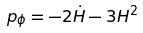<formula> <loc_0><loc_0><loc_500><loc_500>p _ { \phi } = - 2 \dot { H } - 3 H ^ { 2 }</formula> 